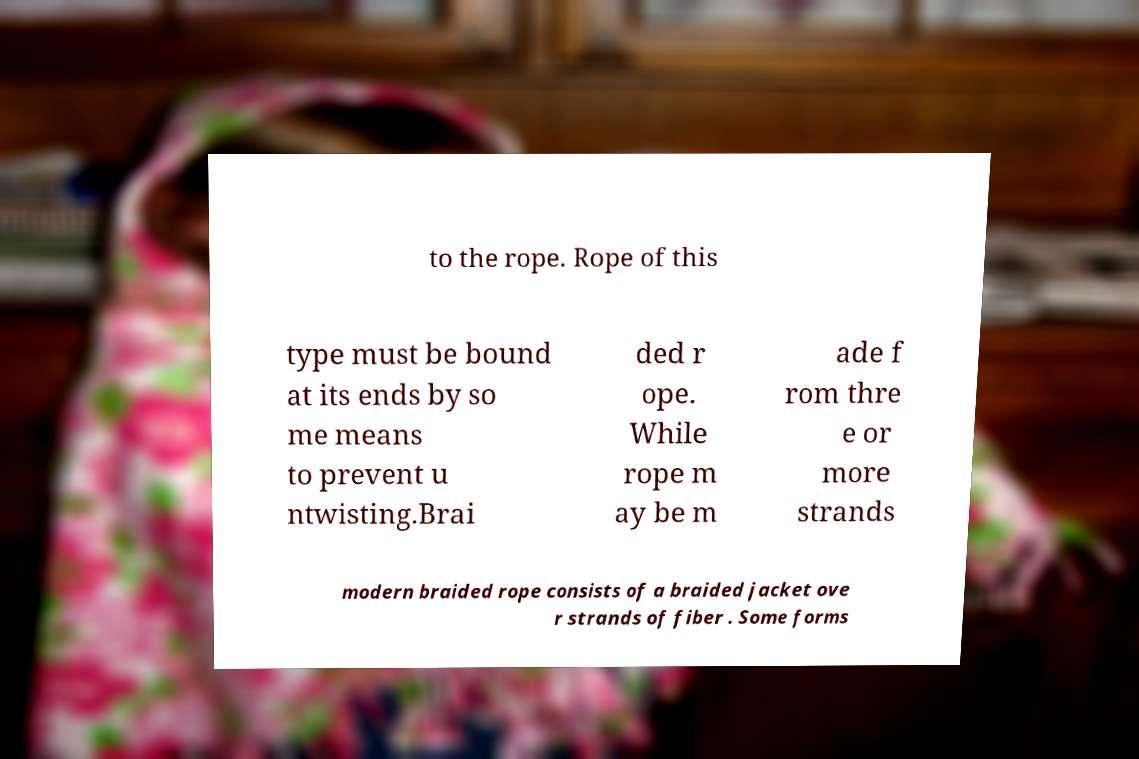Can you accurately transcribe the text from the provided image for me? to the rope. Rope of this type must be bound at its ends by so me means to prevent u ntwisting.Brai ded r ope. While rope m ay be m ade f rom thre e or more strands modern braided rope consists of a braided jacket ove r strands of fiber . Some forms 